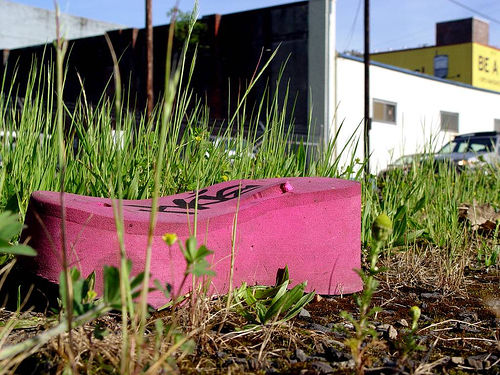<image>
Can you confirm if the sky is behind the wall? Yes. From this viewpoint, the sky is positioned behind the wall, with the wall partially or fully occluding the sky. 